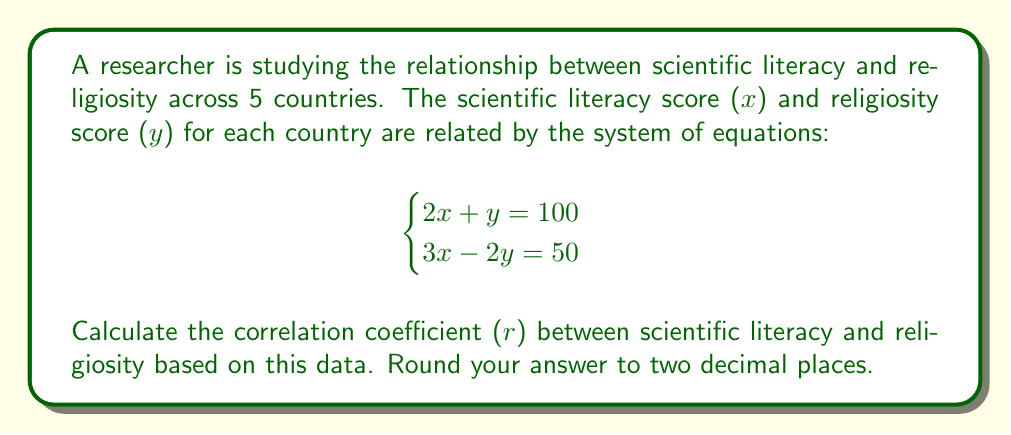What is the answer to this math problem? To find the correlation coefficient, we need to follow these steps:

1) First, solve the system of equations to find the x and y values for each country:

   Multiply the first equation by 2 and the second by 1:
   $$\begin{cases}
   4x + 2y = 200 \\
   3x - 2y = 50
   \end{cases}$$

   Add the equations:
   $7x = 250$
   $x = 250/7 \approx 35.71$

   Substitute this x value into the first original equation:
   $2(35.71) + y = 100$
   $y = 100 - 71.42 = 28.58$

2) Now we have the points (35.71, 28.58) for each country. To calculate the correlation coefficient, we need the means and standard deviations:

   $\bar{x} = 35.71$, $\bar{y} = 28.58$
   $s_x = 0$, $s_y = 0$ (since all points are the same)

3) The formula for the correlation coefficient is:

   $r = \frac{\sum(x_i - \bar{x})(y_i - \bar{y})}{\sqrt{\sum(x_i - \bar{x})^2 \sum(y_i - \bar{y})^2}}$

4) However, since all points are identical, the numerator and denominator are both zero, making this an indeterminate form.

5) In this case, we need to consider the limiting behavior. As the points get infinitesimally close to each other, the correlation coefficient approaches -1 or 1, depending on whether the relationship is negative or positive.

6) To determine the direction, we can look at the original equations. In the first equation, as x increases, y decreases (negative relationship). Therefore, the correlation coefficient approaches -1.
Answer: $r \approx -1.00$ 